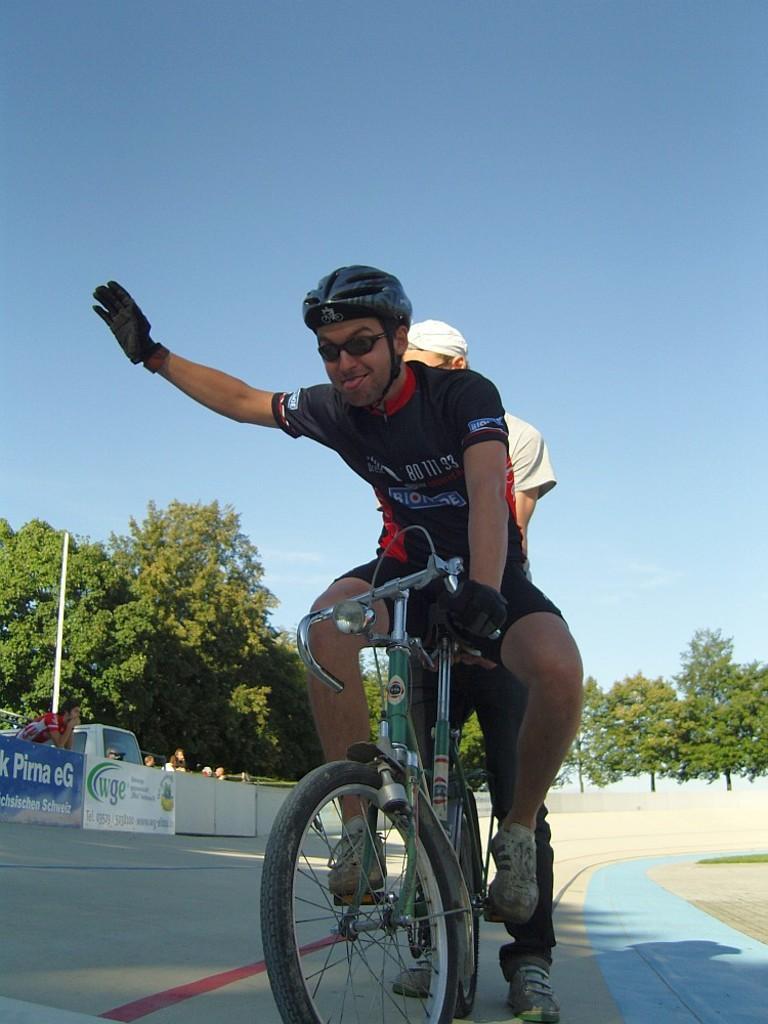How would you summarize this image in a sentence or two? In this image I can see two people are on the bicycle. I can see these people are wearing the different color dresses and I can see one person is having the helmet and the goggles. To the left I can see the banner, few people and the vehicle. In the background there are many trees and the sky. 